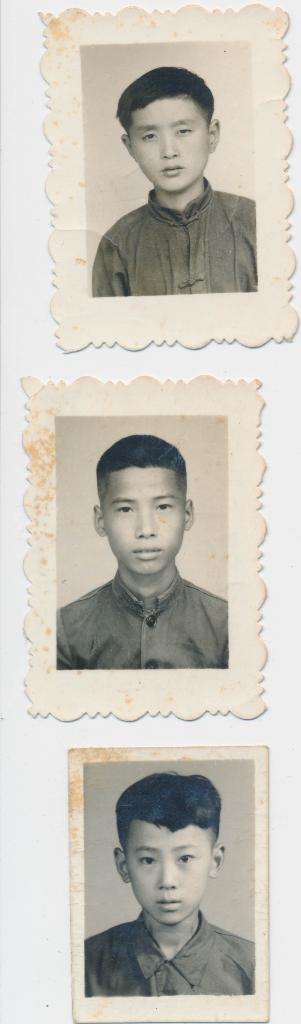What is on the wall in the image? There are photos pasted on the wall in the image. Can you describe the arrangement or content of the photos? Unfortunately, the provided facts do not give enough information to describe the arrangement or content of the photos. Are there any other decorations or items on the wall besides the photos? The provided facts do not mention any other decorations or items on the wall. What type of power does the potato in the image possess? There is no potato present in the image, so it does not possess any power. 